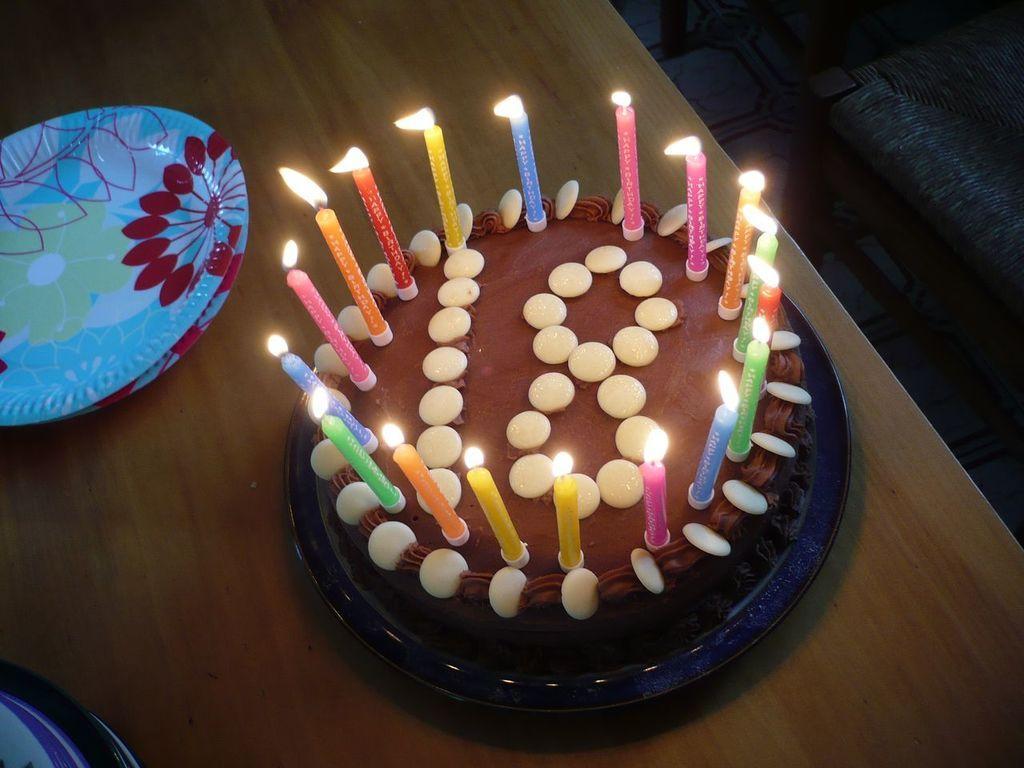Please provide a concise description of this image. In this image we can see a cake with the candles and also the flame. We can also see the two plates placed on the wooden table. 